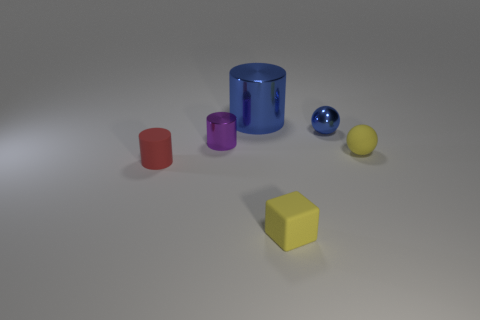The matte cylinder has what color?
Your response must be concise. Red. What number of other objects are there of the same shape as the tiny red rubber thing?
Make the answer very short. 2. Is the number of red things that are in front of the yellow rubber cube the same as the number of red rubber things that are to the right of the red rubber thing?
Give a very brief answer. Yes. What material is the purple cylinder?
Your response must be concise. Metal. What is the material of the small cylinder that is to the right of the tiny rubber cylinder?
Ensure brevity in your answer.  Metal. Is there any other thing that has the same material as the tiny blue object?
Make the answer very short. Yes. Is the number of tiny yellow blocks that are behind the small rubber block greater than the number of large blue objects?
Provide a short and direct response. No. Are there any tiny matte objects that are on the left side of the small yellow object that is in front of the tiny matte object that is behind the small red matte cylinder?
Your answer should be very brief. Yes. Are there any tiny yellow rubber objects on the right side of the tiny blue object?
Provide a short and direct response. Yes. How many tiny cylinders are the same color as the tiny rubber ball?
Your response must be concise. 0. 